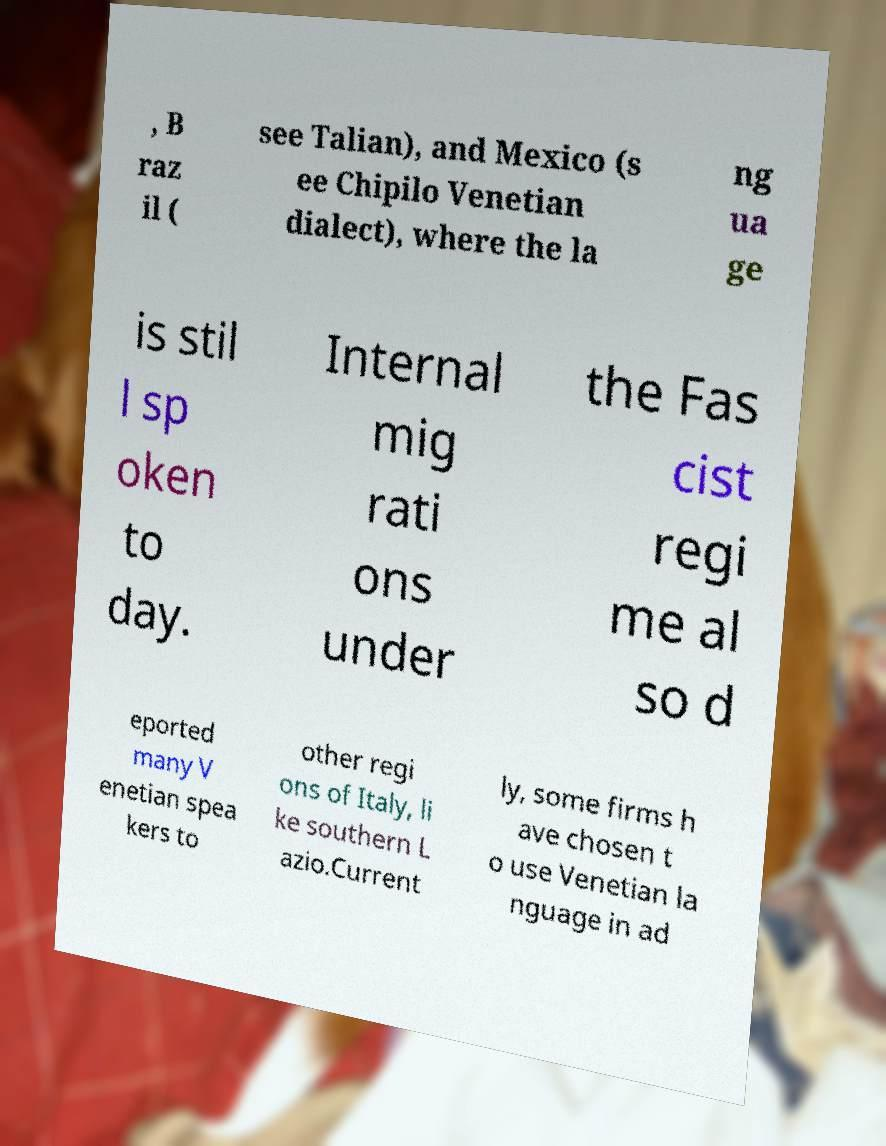Please identify and transcribe the text found in this image. , B raz il ( see Talian), and Mexico (s ee Chipilo Venetian dialect), where the la ng ua ge is stil l sp oken to day. Internal mig rati ons under the Fas cist regi me al so d eported many V enetian spea kers to other regi ons of Italy, li ke southern L azio.Current ly, some firms h ave chosen t o use Venetian la nguage in ad 